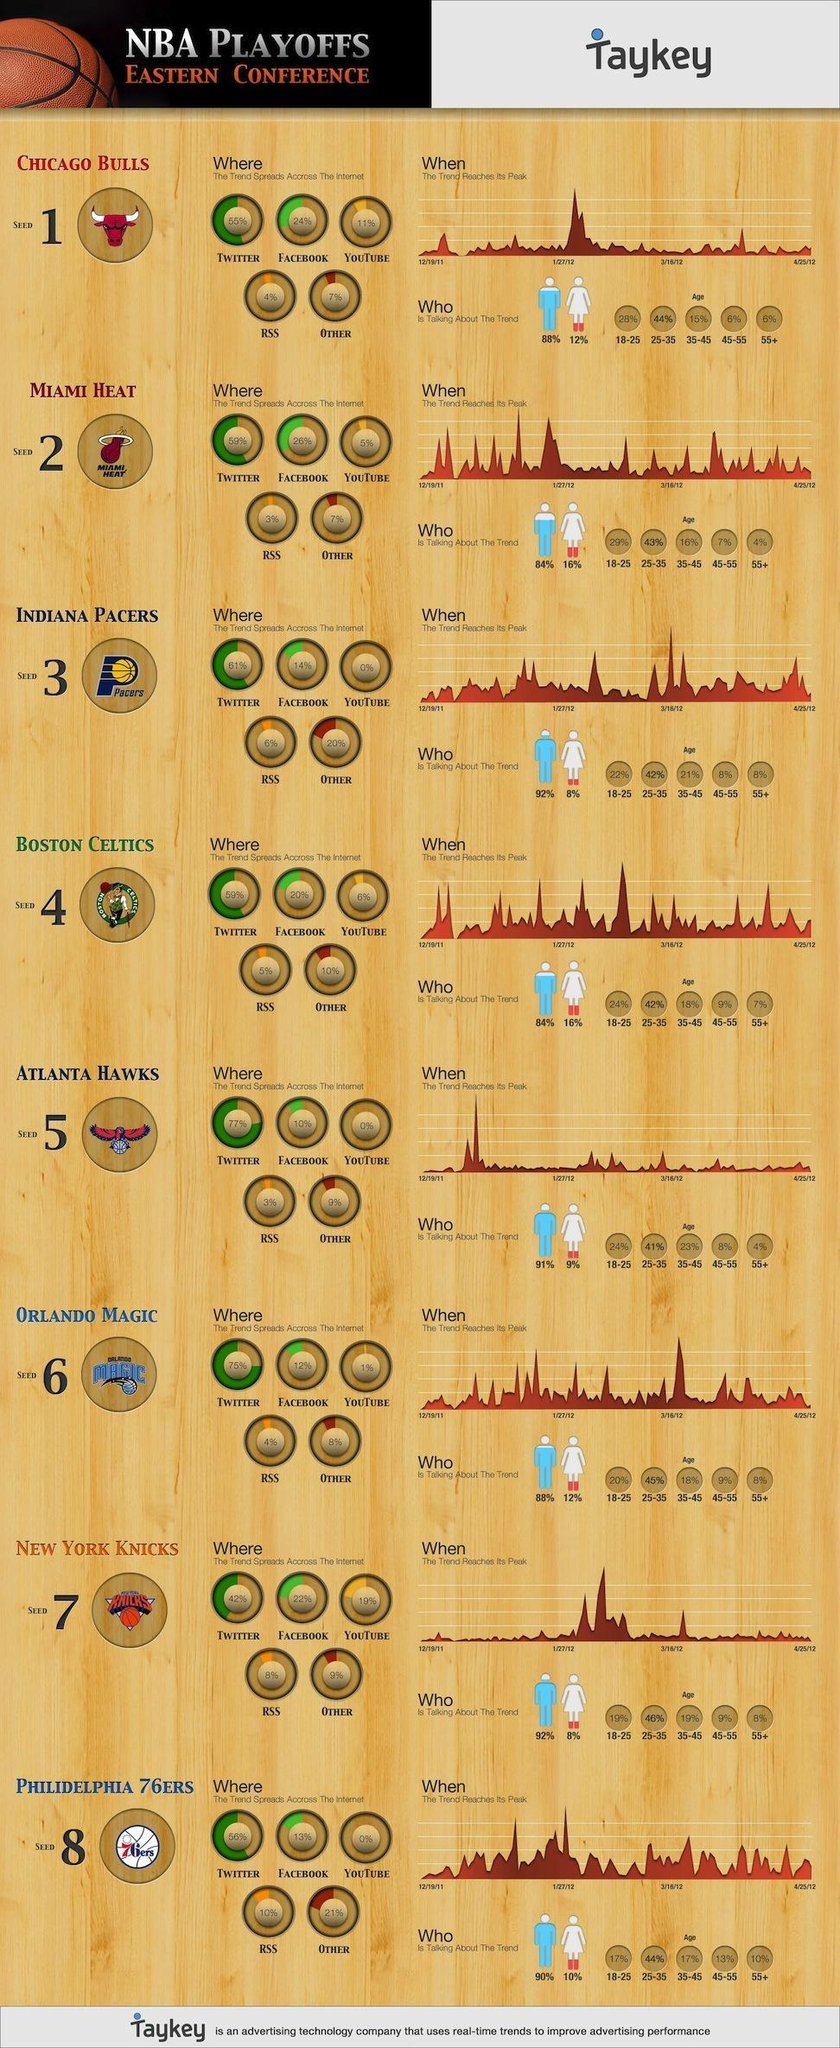What is the colour of then ball in the logo of New york knicks, orange or white
Answer the question with a short phrase. orange What is written inside the logo of Philidelphia 76ers 76ers What is the total % of twitter and facebook for chicago bulls 79 What % of males are talking about Boston Celtics 84% What is the total % in youtube for Indiana Pacers 0% What % of females are talking about Orlando Magic 12% What % of females are talking about Chicago bulls 12% 